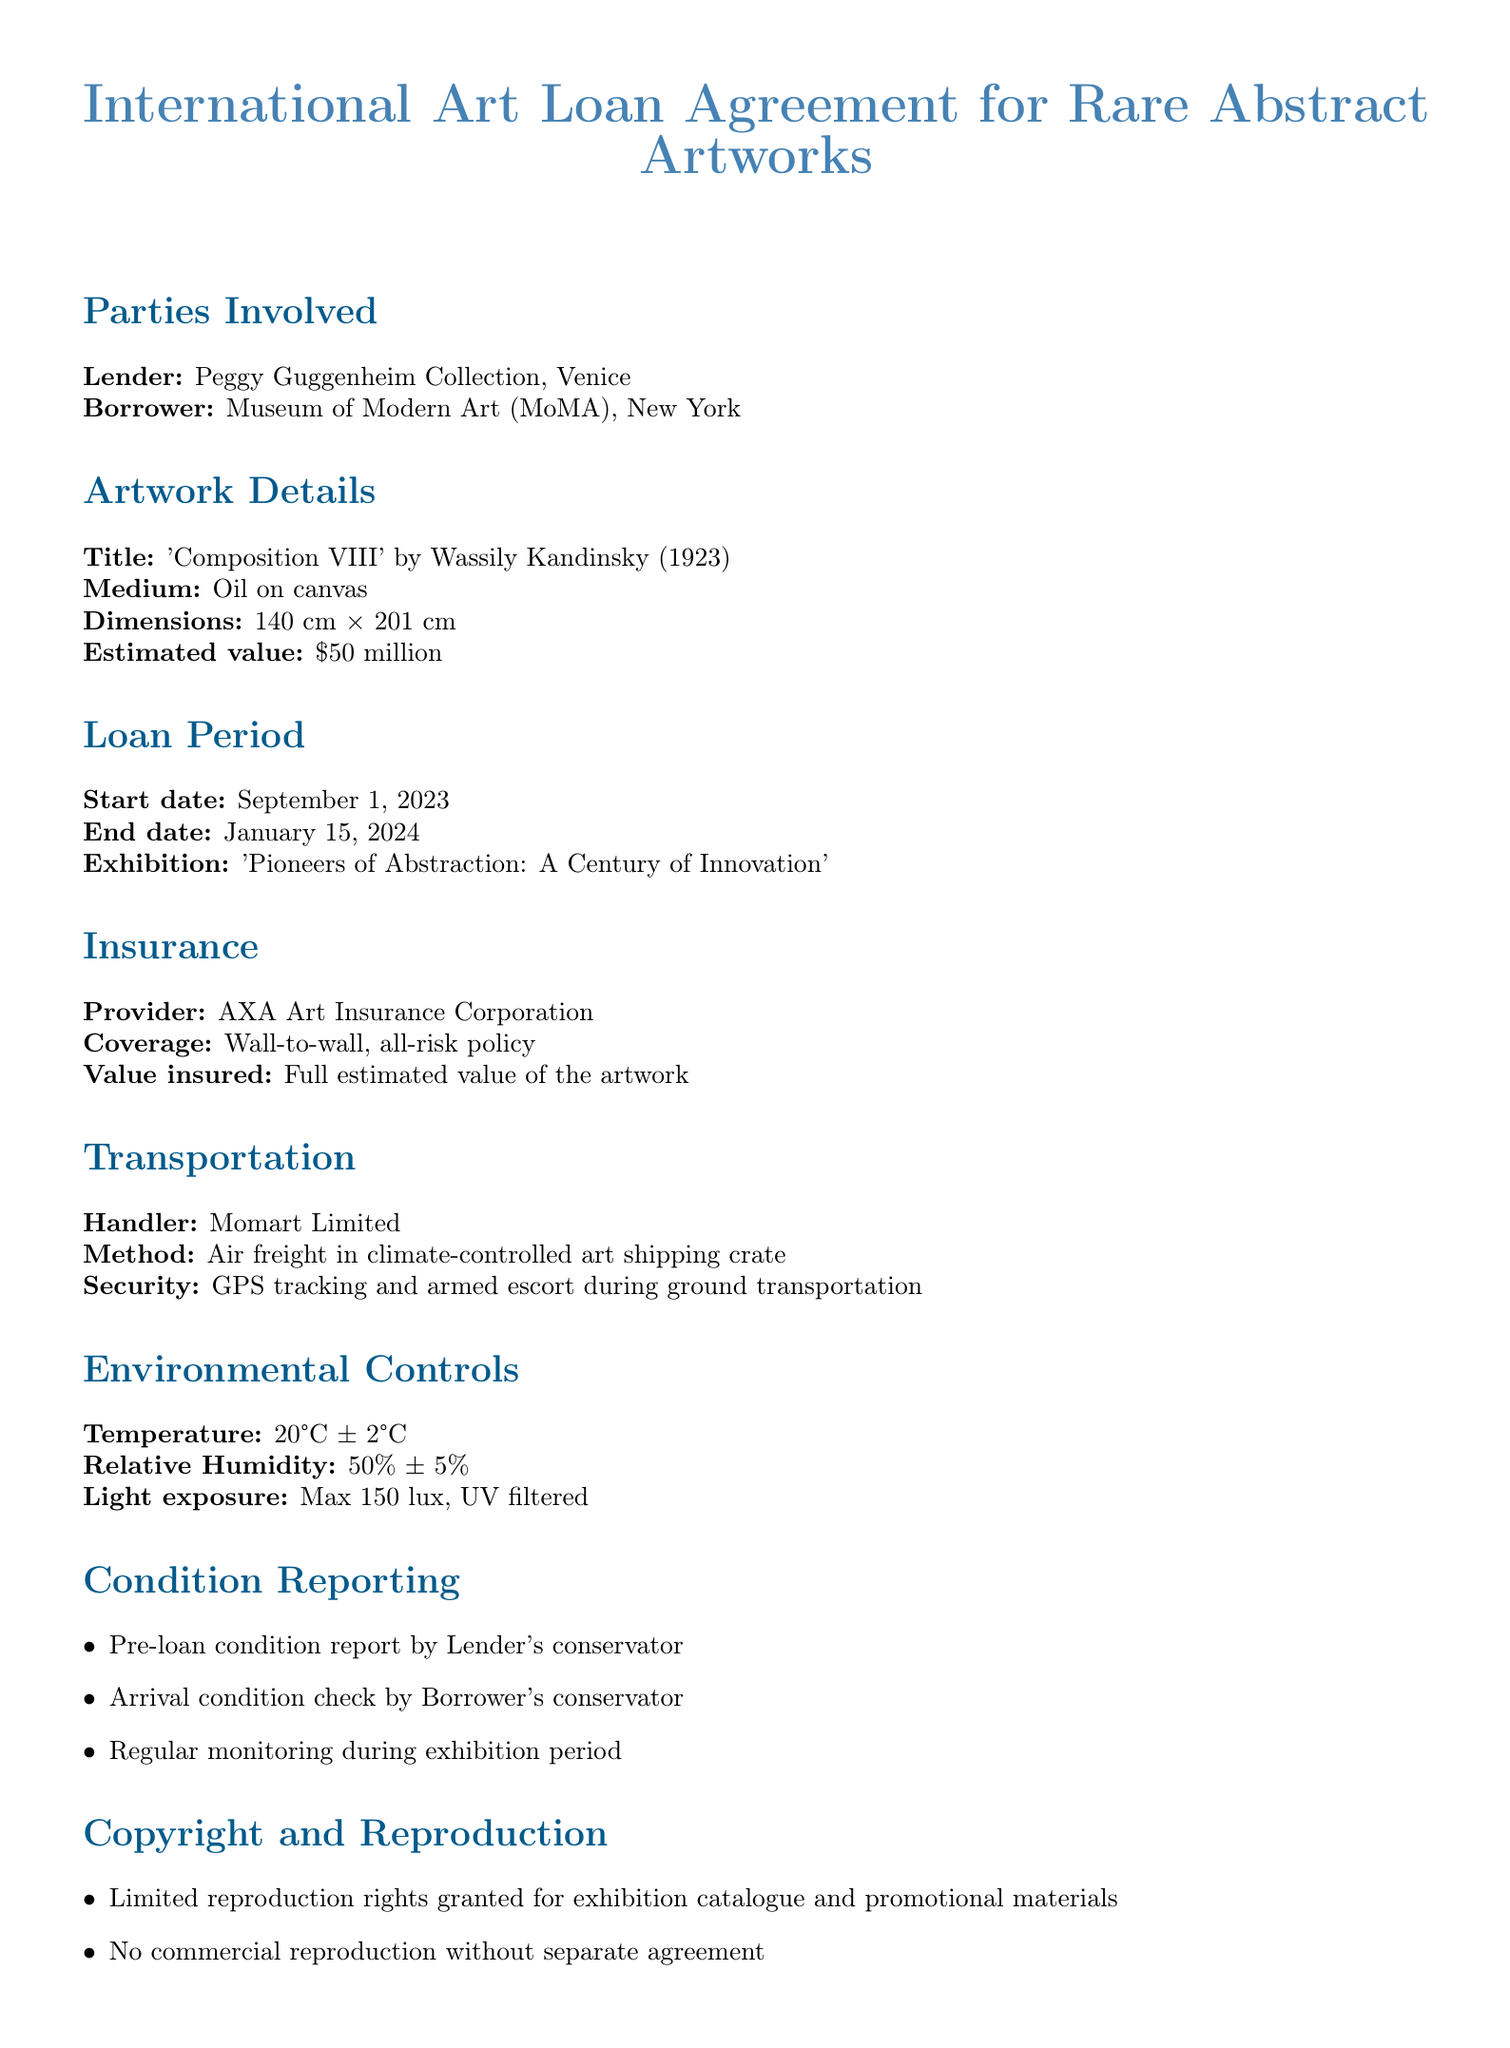What is the lender's name? The lender is identified at the beginning of the document, stating "Lender: Peggy Guggenheim Collection, Venice."
Answer: Peggy Guggenheim Collection, Venice What is the medium of the artwork? The medium of the artwork is specified within the artwork details section, stating "Medium: Oil on canvas."
Answer: Oil on canvas What is the estimated value of the artwork? The estimated value is clearly stated in the artwork details as "$50 million."
Answer: $50 million What is the loan end date? The end date of the loan is provided in the loan period section as "January 15, 2024."
Answer: January 15, 2024 What is the temperature requirement for environmental controls? The document specifies "Temperature: 20°C ± 2°C" under environmental controls.
Answer: 20°C ± 2°C Who handles the transportation of the artwork? The document lists the handler in the transportation section as "Momart Limited."
Answer: Momart Limited What type of insurance coverage is provided? The insurance type is described as "Wall-to-wall, all-risk policy" in the insurance section.
Answer: Wall-to-wall, all-risk policy What are the humidity specifications in the environmental controls? The relative humidity is mentioned as "50% ± 5%" in the environmental controls section.
Answer: 50% ± 5% What are the limited reproduction rights for? The document states that limited reproduction rights are granted for "exhibition catalogue and promotional materials."
Answer: exhibition catalogue and promotional materials 